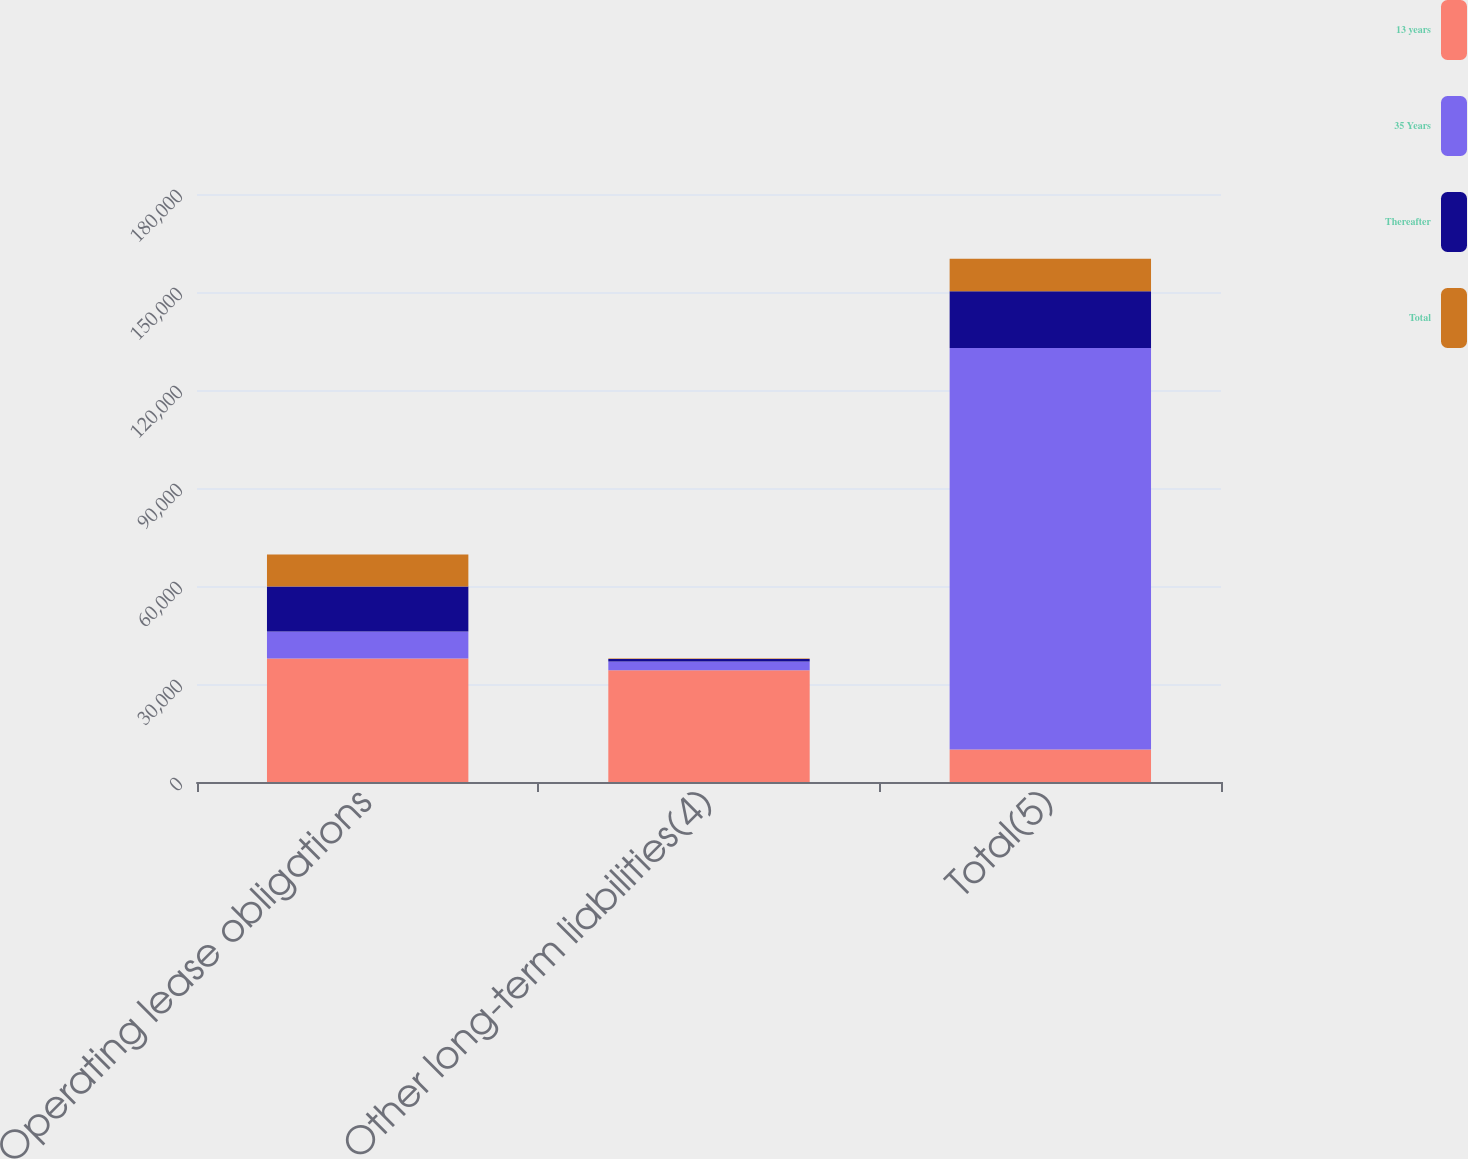Convert chart to OTSL. <chart><loc_0><loc_0><loc_500><loc_500><stacked_bar_chart><ecel><fcel>Operating lease obligations<fcel>Other long-term liabilities(4)<fcel>Total(5)<nl><fcel>13 years<fcel>37788<fcel>34199<fcel>9926<nl><fcel>35 Years<fcel>8247<fcel>2683<fcel>122963<nl><fcel>Thereafter<fcel>13819<fcel>769<fcel>17360<nl><fcel>Total<fcel>9780<fcel>146<fcel>9926<nl></chart> 